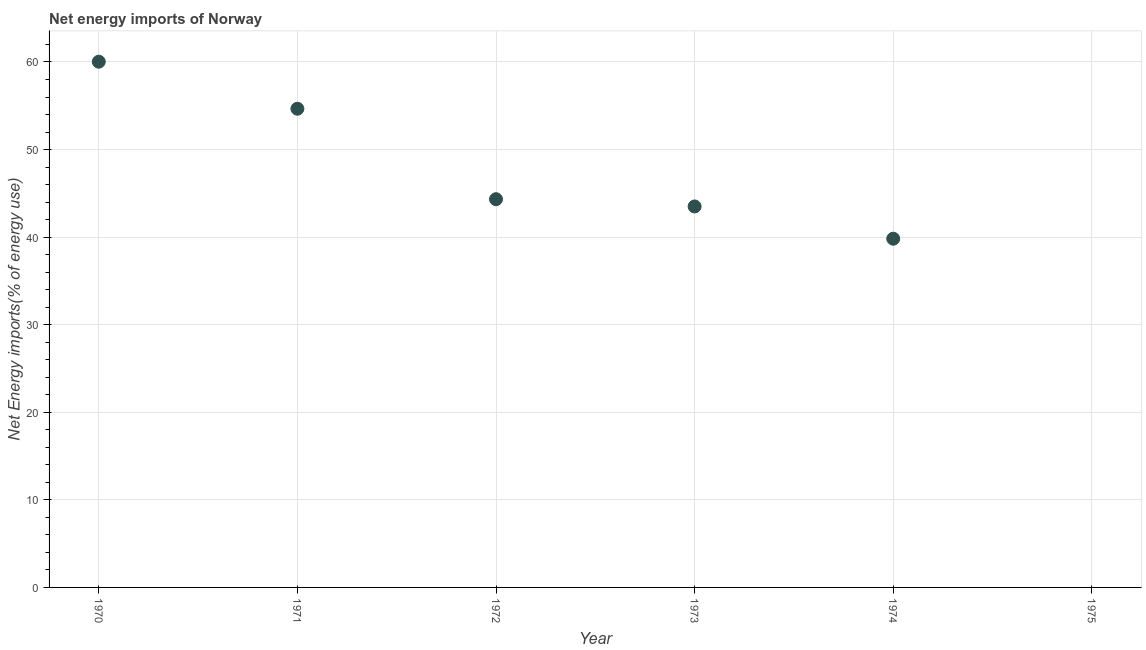What is the energy imports in 1973?
Your answer should be very brief. 43.5. Across all years, what is the maximum energy imports?
Offer a terse response. 60.03. Across all years, what is the minimum energy imports?
Your answer should be compact. 0. What is the sum of the energy imports?
Keep it short and to the point. 242.34. What is the difference between the energy imports in 1970 and 1974?
Your answer should be compact. 20.21. What is the average energy imports per year?
Your answer should be compact. 40.39. What is the median energy imports?
Your answer should be very brief. 43.92. In how many years, is the energy imports greater than 58 %?
Ensure brevity in your answer.  1. What is the ratio of the energy imports in 1973 to that in 1974?
Provide a succinct answer. 1.09. What is the difference between the highest and the second highest energy imports?
Make the answer very short. 5.37. What is the difference between the highest and the lowest energy imports?
Provide a short and direct response. 60.03. In how many years, is the energy imports greater than the average energy imports taken over all years?
Offer a terse response. 4. What is the difference between two consecutive major ticks on the Y-axis?
Your answer should be compact. 10. Does the graph contain any zero values?
Your answer should be compact. Yes. Does the graph contain grids?
Provide a short and direct response. Yes. What is the title of the graph?
Keep it short and to the point. Net energy imports of Norway. What is the label or title of the X-axis?
Offer a terse response. Year. What is the label or title of the Y-axis?
Your answer should be very brief. Net Energy imports(% of energy use). What is the Net Energy imports(% of energy use) in 1970?
Give a very brief answer. 60.03. What is the Net Energy imports(% of energy use) in 1971?
Offer a very short reply. 54.66. What is the Net Energy imports(% of energy use) in 1972?
Your answer should be very brief. 44.33. What is the Net Energy imports(% of energy use) in 1973?
Your answer should be very brief. 43.5. What is the Net Energy imports(% of energy use) in 1974?
Keep it short and to the point. 39.82. What is the difference between the Net Energy imports(% of energy use) in 1970 and 1971?
Your answer should be compact. 5.37. What is the difference between the Net Energy imports(% of energy use) in 1970 and 1972?
Your response must be concise. 15.7. What is the difference between the Net Energy imports(% of energy use) in 1970 and 1973?
Provide a succinct answer. 16.53. What is the difference between the Net Energy imports(% of energy use) in 1970 and 1974?
Ensure brevity in your answer.  20.21. What is the difference between the Net Energy imports(% of energy use) in 1971 and 1972?
Your response must be concise. 10.33. What is the difference between the Net Energy imports(% of energy use) in 1971 and 1973?
Offer a very short reply. 11.16. What is the difference between the Net Energy imports(% of energy use) in 1971 and 1974?
Your response must be concise. 14.84. What is the difference between the Net Energy imports(% of energy use) in 1972 and 1973?
Offer a terse response. 0.83. What is the difference between the Net Energy imports(% of energy use) in 1972 and 1974?
Give a very brief answer. 4.51. What is the difference between the Net Energy imports(% of energy use) in 1973 and 1974?
Offer a very short reply. 3.68. What is the ratio of the Net Energy imports(% of energy use) in 1970 to that in 1971?
Provide a succinct answer. 1.1. What is the ratio of the Net Energy imports(% of energy use) in 1970 to that in 1972?
Give a very brief answer. 1.35. What is the ratio of the Net Energy imports(% of energy use) in 1970 to that in 1973?
Provide a succinct answer. 1.38. What is the ratio of the Net Energy imports(% of energy use) in 1970 to that in 1974?
Provide a succinct answer. 1.51. What is the ratio of the Net Energy imports(% of energy use) in 1971 to that in 1972?
Your answer should be compact. 1.23. What is the ratio of the Net Energy imports(% of energy use) in 1971 to that in 1973?
Your answer should be very brief. 1.26. What is the ratio of the Net Energy imports(% of energy use) in 1971 to that in 1974?
Your answer should be very brief. 1.37. What is the ratio of the Net Energy imports(% of energy use) in 1972 to that in 1973?
Keep it short and to the point. 1.02. What is the ratio of the Net Energy imports(% of energy use) in 1972 to that in 1974?
Give a very brief answer. 1.11. What is the ratio of the Net Energy imports(% of energy use) in 1973 to that in 1974?
Your answer should be very brief. 1.09. 